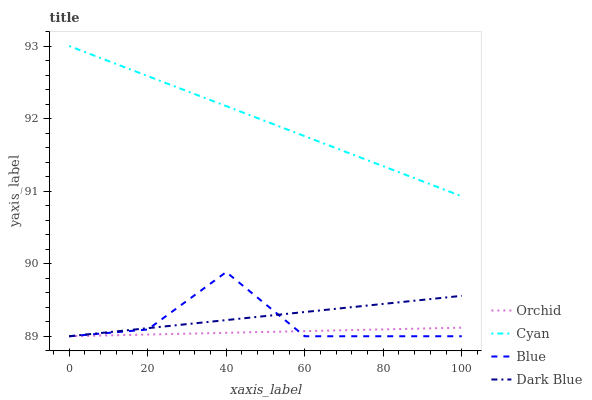Does Orchid have the minimum area under the curve?
Answer yes or no. Yes. Does Cyan have the maximum area under the curve?
Answer yes or no. Yes. Does Dark Blue have the minimum area under the curve?
Answer yes or no. No. Does Dark Blue have the maximum area under the curve?
Answer yes or no. No. Is Cyan the smoothest?
Answer yes or no. Yes. Is Blue the roughest?
Answer yes or no. Yes. Is Dark Blue the smoothest?
Answer yes or no. No. Is Dark Blue the roughest?
Answer yes or no. No. Does Blue have the lowest value?
Answer yes or no. Yes. Does Cyan have the lowest value?
Answer yes or no. No. Does Cyan have the highest value?
Answer yes or no. Yes. Does Dark Blue have the highest value?
Answer yes or no. No. Is Orchid less than Cyan?
Answer yes or no. Yes. Is Cyan greater than Blue?
Answer yes or no. Yes. Does Blue intersect Orchid?
Answer yes or no. Yes. Is Blue less than Orchid?
Answer yes or no. No. Is Blue greater than Orchid?
Answer yes or no. No. Does Orchid intersect Cyan?
Answer yes or no. No. 